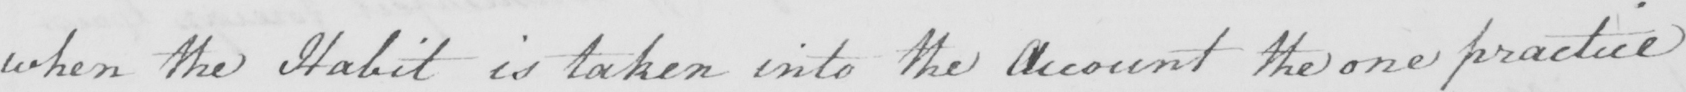Please transcribe the handwritten text in this image. when the Habit is taken into the Account the one practice 